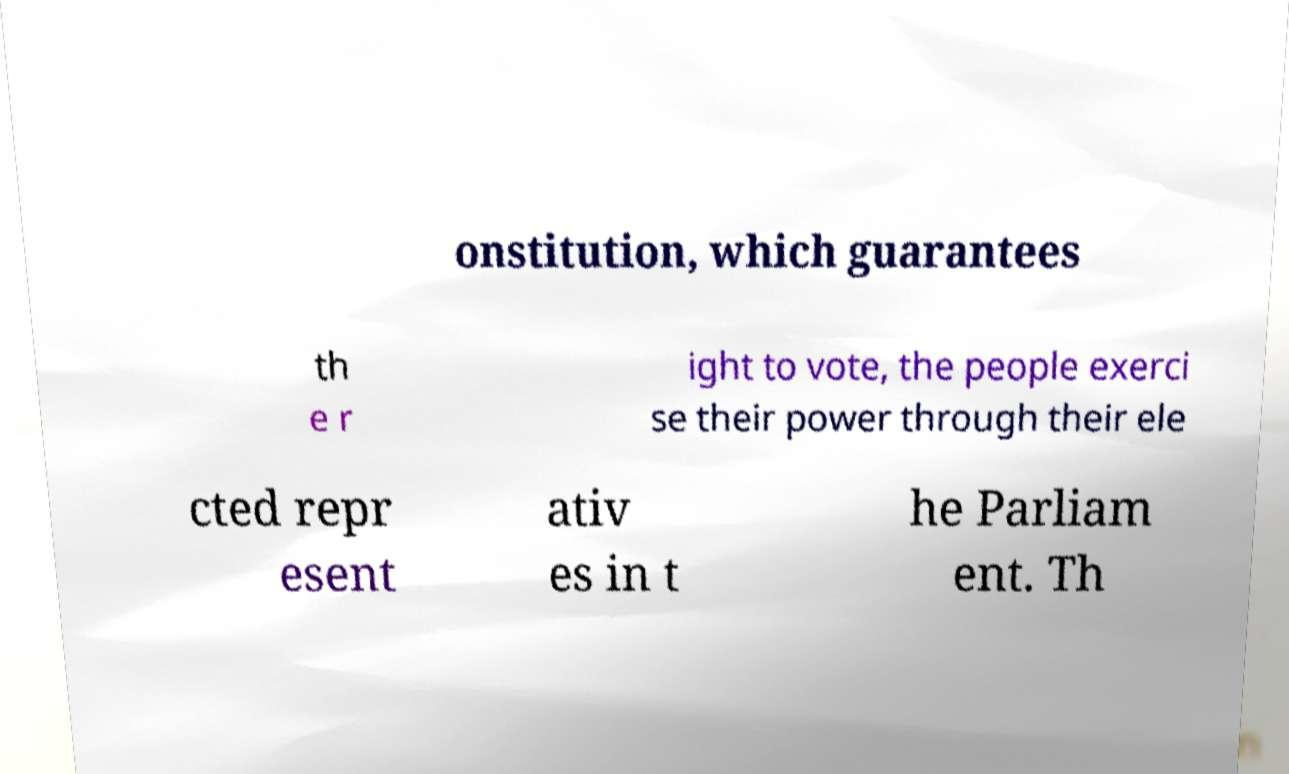I need the written content from this picture converted into text. Can you do that? onstitution, which guarantees th e r ight to vote, the people exerci se their power through their ele cted repr esent ativ es in t he Parliam ent. Th 